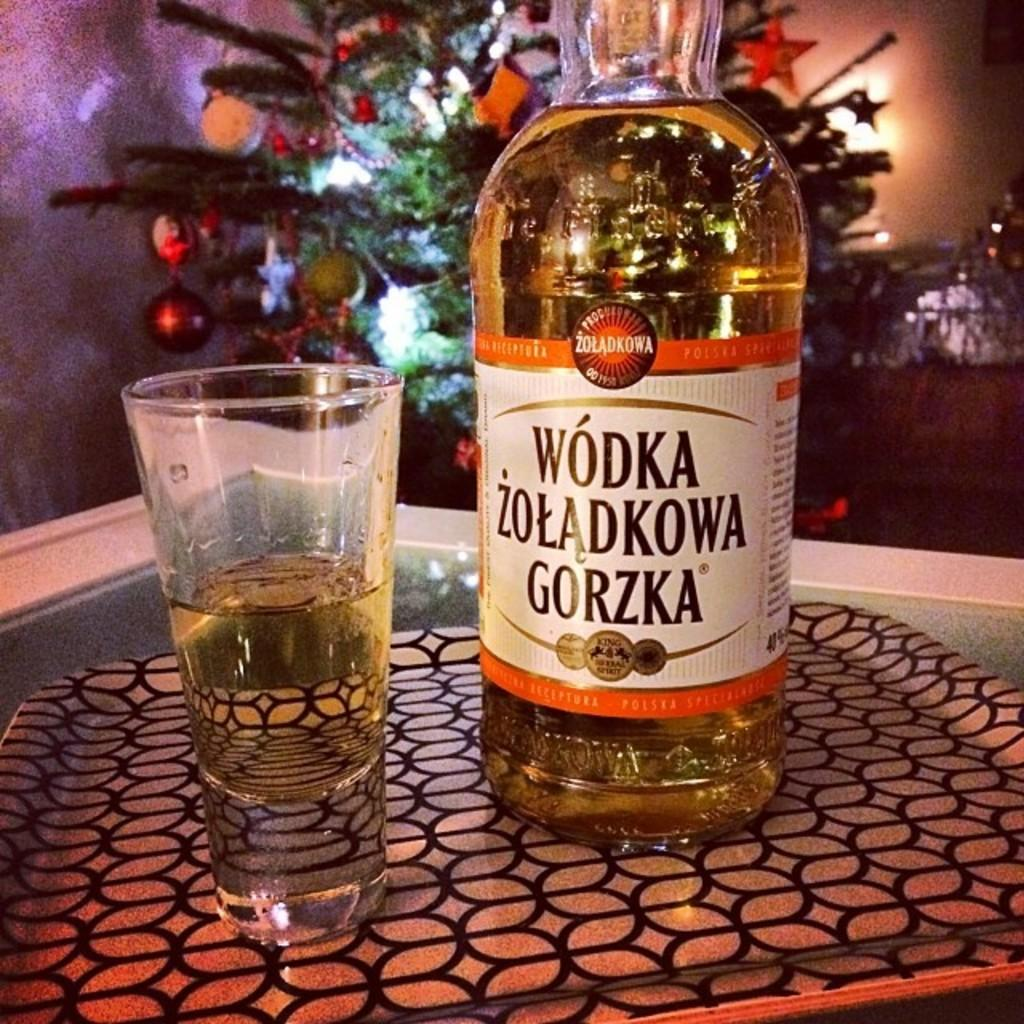<image>
Create a compact narrative representing the image presented. Bottle of alcohol named WODKA ZOLADKOWA GORZKA on top of a tray. 